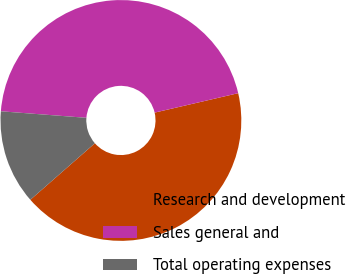Convert chart to OTSL. <chart><loc_0><loc_0><loc_500><loc_500><pie_chart><fcel>Research and development<fcel>Sales general and<fcel>Total operating expenses<nl><fcel>42.19%<fcel>45.15%<fcel>12.66%<nl></chart> 